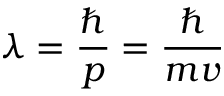<formula> <loc_0><loc_0><loc_500><loc_500>\lambda = \frac { } { p } = \frac { } { m v }</formula> 